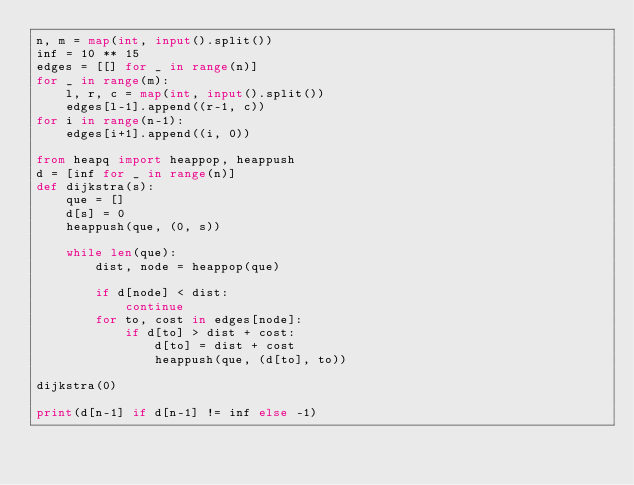<code> <loc_0><loc_0><loc_500><loc_500><_Python_>n, m = map(int, input().split())
inf = 10 ** 15
edges = [[] for _ in range(n)]
for _ in range(m):
    l, r, c = map(int, input().split())
    edges[l-1].append((r-1, c))
for i in range(n-1):
    edges[i+1].append((i, 0))

from heapq import heappop, heappush
d = [inf for _ in range(n)]
def dijkstra(s):
    que = []
    d[s] = 0
    heappush(que, (0, s))

    while len(que):
        dist, node = heappop(que)

        if d[node] < dist:
            continue
        for to, cost in edges[node]:
            if d[to] > dist + cost:
                d[to] = dist + cost
                heappush(que, (d[to], to))

dijkstra(0)

print(d[n-1] if d[n-1] != inf else -1)</code> 